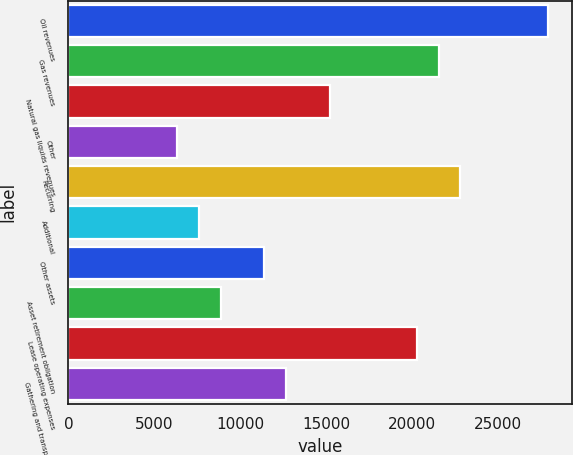Convert chart. <chart><loc_0><loc_0><loc_500><loc_500><bar_chart><fcel>Oil revenues<fcel>Gas revenues<fcel>Natural gas liquids revenues<fcel>Other<fcel>Recurring<fcel>Additional<fcel>Other assets<fcel>Asset retirement obligation<fcel>Lease operating expenses<fcel>Gathering and transportation<nl><fcel>27893.1<fcel>21553.9<fcel>15214.7<fcel>6339.8<fcel>22821.7<fcel>7607.64<fcel>11411.2<fcel>8875.48<fcel>20286<fcel>12679<nl></chart> 